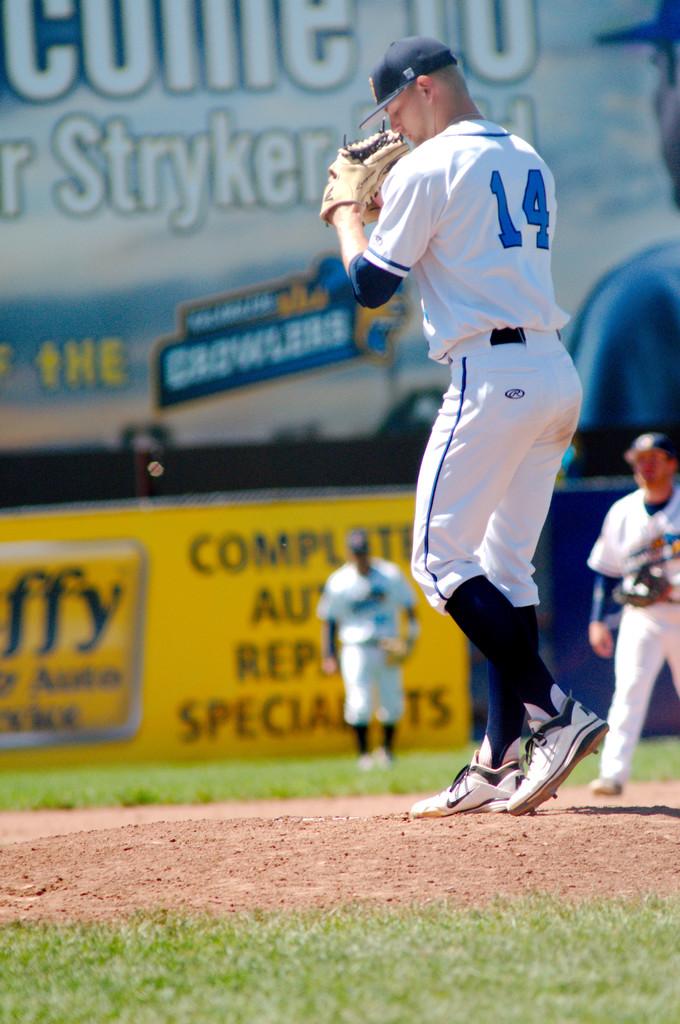What is this players position that is wearing number 14?
Ensure brevity in your answer.  Pitcher. 